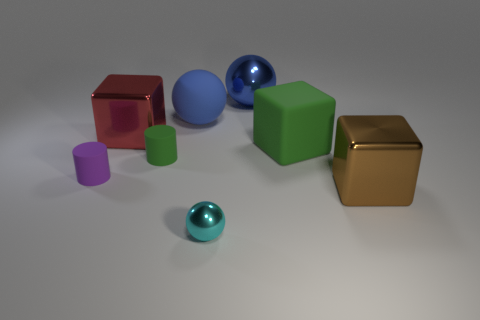What number of large blue balls are the same material as the big brown thing?
Provide a succinct answer. 1. Is there a matte object left of the cube on the left side of the green matte block that is on the right side of the tiny green cylinder?
Provide a succinct answer. Yes. What number of blocks are either large brown things or small blue objects?
Give a very brief answer. 1. Does the red metal thing have the same shape as the matte object that is behind the red object?
Offer a very short reply. No. Are there fewer cyan objects in front of the tiny sphere than small green metal objects?
Provide a succinct answer. No. There is a purple object; are there any large metal blocks in front of it?
Your answer should be compact. Yes. Is there a small cyan rubber thing that has the same shape as the large blue shiny thing?
Your answer should be very brief. No. The blue rubber object that is the same size as the brown shiny block is what shape?
Keep it short and to the point. Sphere. What number of things are tiny matte things that are to the left of the green cylinder or large shiny blocks?
Make the answer very short. 3. Do the tiny metal object and the matte sphere have the same color?
Offer a very short reply. No. 